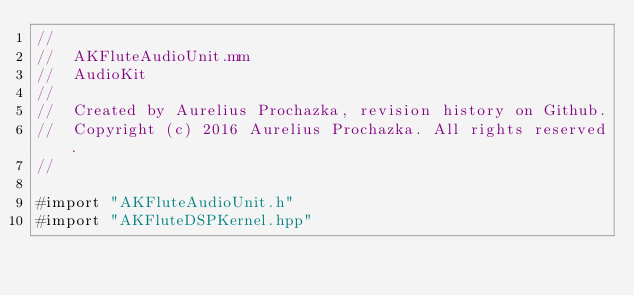<code> <loc_0><loc_0><loc_500><loc_500><_ObjectiveC_>//
//  AKFluteAudioUnit.mm
//  AudioKit
//
//  Created by Aurelius Prochazka, revision history on Github.
//  Copyright (c) 2016 Aurelius Prochazka. All rights reserved.
//

#import "AKFluteAudioUnit.h"
#import "AKFluteDSPKernel.hpp"
</code> 